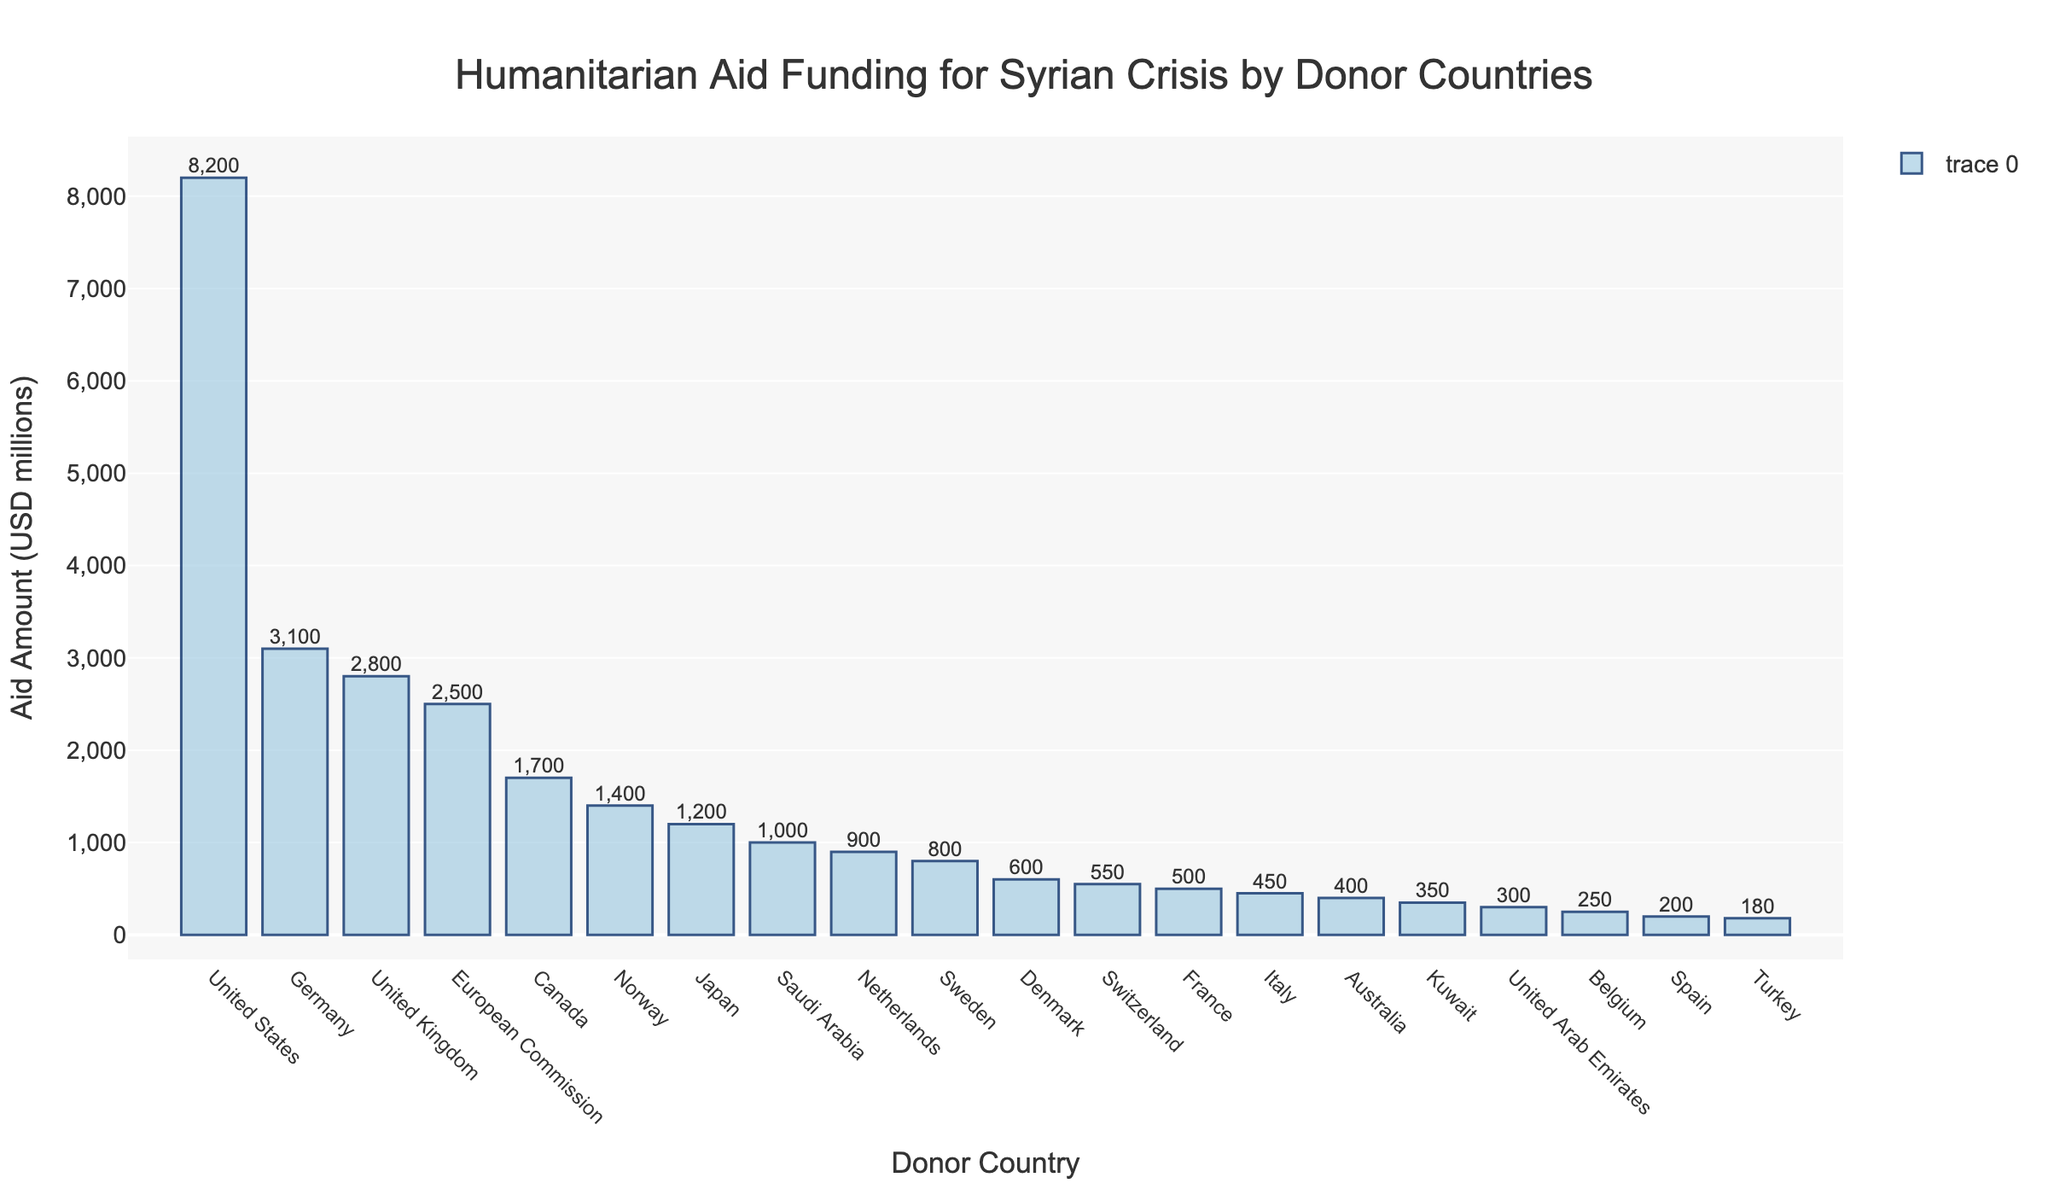What country contributed the most humanitarian aid for the Syrian crisis? The tallest bar represents the United States, indicating that it contributed the most humanitarian aid.
Answer: United States Which two countries contributed the least amount of aid, and how much did they contribute together? The shortest bars represent Turkey and Spain, which contributed $180 million and $200 million respectively. Adding these together gives $380 million.
Answer: Turkey and Spain, $380 million How much more aid did Germany contribute compared to the United Kingdom? Germany's aid amount is $3,100 million, whereas the UK's is $2,800 million. The difference between them is $3,100 million - $2,800 million = $300 million.
Answer: $300 million What is the total amount of aid contributed by European countries (excluding European Commission)? Adding the contributions of Germany ($3,100 million), United Kingdom ($2,800 million), Norway ($1,400 million), Netherlands ($900 million), Sweden ($800 million), Denmark ($600 million), Switzerland ($550 million), France ($500 million), Italy ($450 million), Belgium ($250 million), and Spain ($200 million) gives a total of $11,550 million.
Answer: $11,550 million Which donor countries contributed amounts between $300 million and $400 million inclusive? Looking at the bars, Australia and Kuwait contributed amounts in this range with $400 million and $350 million respectively.
Answer: Australia and Kuwait What is the combined aid amount from Saudi Arabia and the United Arab Emirates? Adding the contributions from Saudi Arabia ($1,000 million) and the United Arab Emirates ($300 million) gives $1,300 million.
Answer: $1,300 million Which country contributed exactly half of the amount that Japan did? Japan contributed $1,200 million, and half of this amount is $600 million. The country contributing $600 million, as indicated by the bar, is Denmark.
Answer: Denmark What percentage of the total aid does the contribution from the United States represent? The total aid can be summed up by adding all the amounts: $8,200m + $3,100m + $2,800m + $2,500m + $1,700m + $1,400m + $1,200m + $1,000m + $900m + $800m + $600m + $550m + $500m + $450m + $400m + $350m + $300m + $250m + $200m + $180m = $26,380m. The percentage is then ($8,200m / $26,380m) * 100 ≈ 31.1%.
Answer: 31.1% Which three European countries contributed the most aid, and what is the total amount they contributed? The three countries with the tallest bars among European countries are Germany ($3,100 million), United Kingdom ($2,800 million), and Norway ($1,400 million). Adding these gives a total of $7,300 million.
Answer: Germany, United Kingdom, and Norway, $7,300 million What is the average aid amount contributed by the top 5 donor countries? The top 5 countries and their contributions are the United States ($8,200 million), Germany ($3,100 million), United Kingdom ($2,800 million), European Commission ($2,500 million), and Canada ($1,700 million). The sum is $18,300 million, and the average is $18,300m / 5 = $3,660 million.
Answer: $3,660 million 